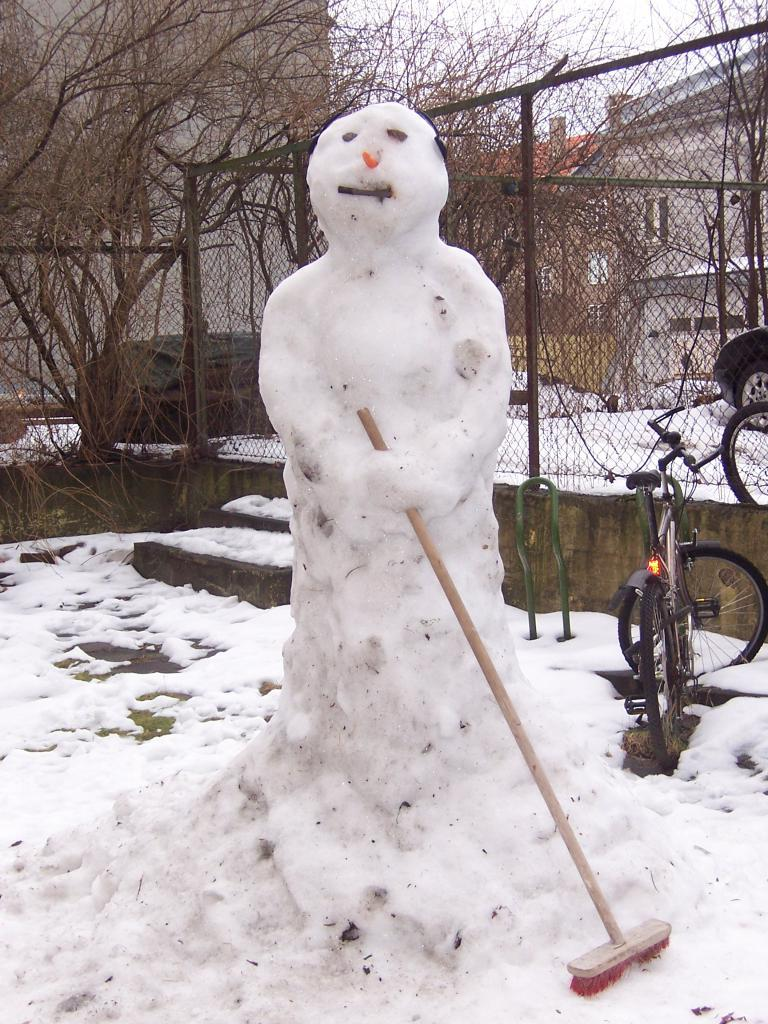What is the main subject in the foreground of the image? There is a snowman in the foreground of the image. What is the snowman holding? The snowman is holding a brush. What can be seen in the background of the image? There is snow, a net, stairs, cycles, buildings, and trees in the background of the image. Can you tell me how many beads are on the girl's necklace in the image? There is no girl or necklace present in the image; it features a snowman holding a brush in the foreground and various elements in the background. What type of camera is being used to take the picture in the image? There is no camera visible in the image, as it is a photograph of a scene featuring a snowman and various elements in the background. 